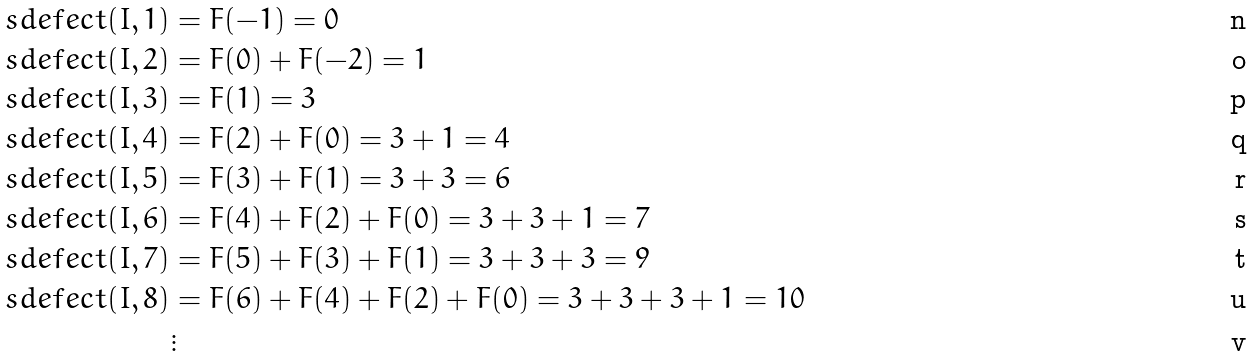<formula> <loc_0><loc_0><loc_500><loc_500>\ s d e f e c t ( I , 1 ) & = F ( - 1 ) = 0 \\ \ s d e f e c t ( I , 2 ) & = F ( 0 ) + F ( - 2 ) = 1 \\ \ s d e f e c t ( I , 3 ) & = F ( 1 ) = 3 \\ \ s d e f e c t ( I , 4 ) & = F ( 2 ) + F ( 0 ) = 3 + 1 = 4 \\ \ s d e f e c t ( I , 5 ) & = F ( 3 ) + F ( 1 ) = 3 + 3 = 6 \\ \ s d e f e c t ( I , 6 ) & = F ( 4 ) + F ( 2 ) + F ( 0 ) = 3 + 3 + 1 = 7 \\ \ s d e f e c t ( I , 7 ) & = F ( 5 ) + F ( 3 ) + F ( 1 ) = 3 + 3 + 3 = 9 \\ \ s d e f e c t ( I , 8 ) & = F ( 6 ) + F ( 4 ) + F ( 2 ) + F ( 0 ) = 3 + 3 + 3 + 1 = 1 0 \\ & \vdots</formula> 